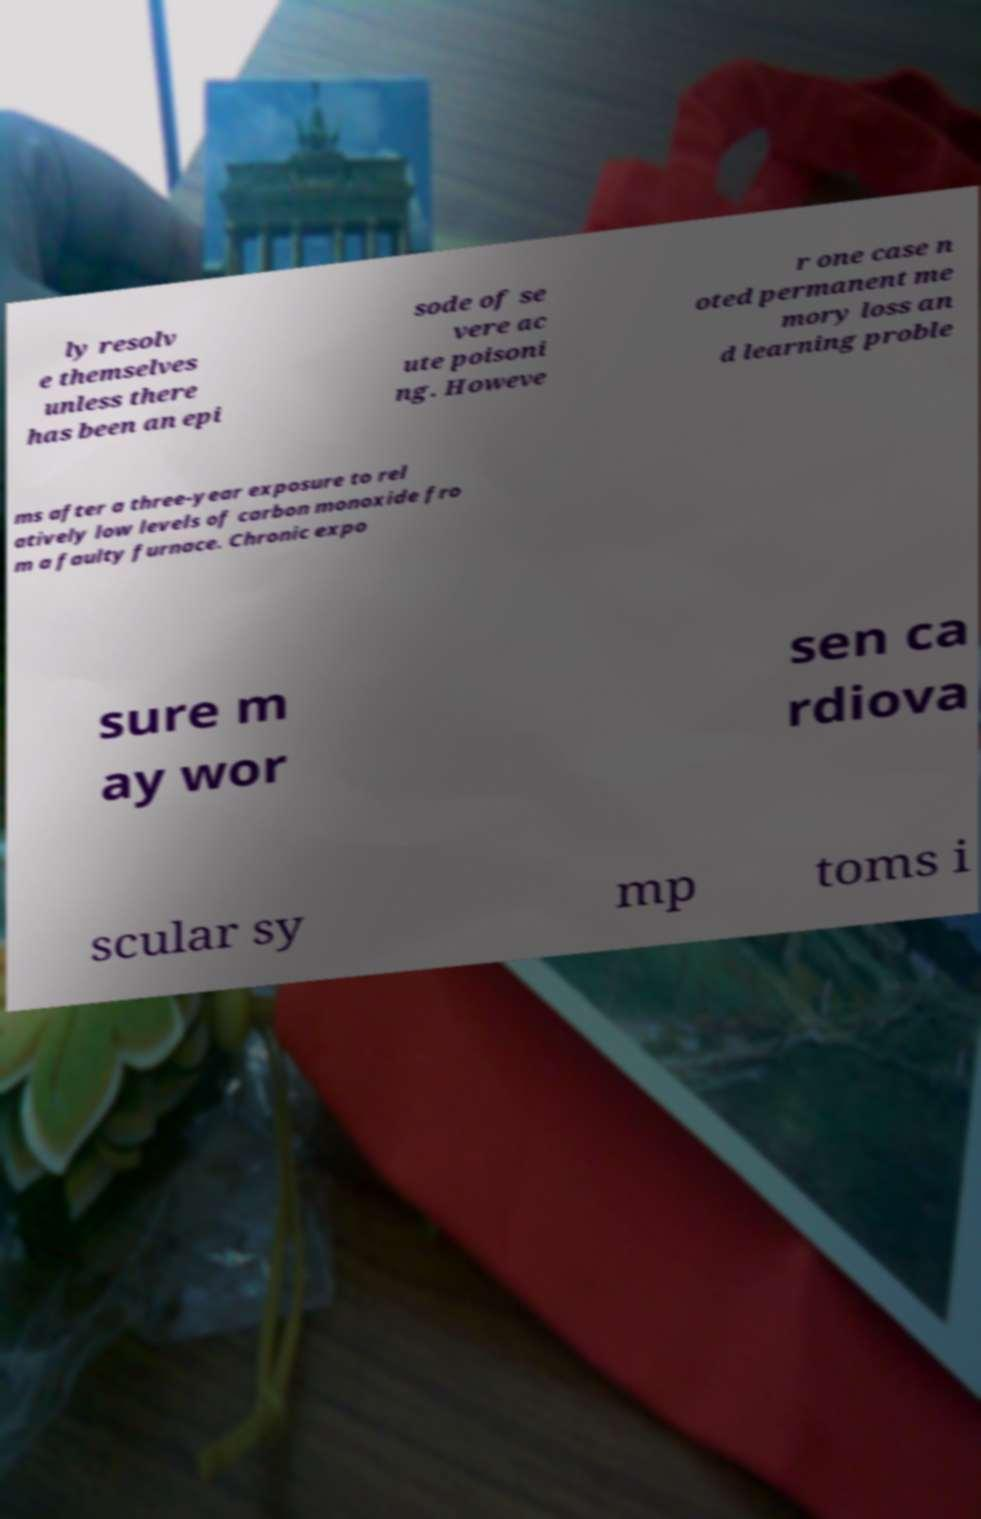Please identify and transcribe the text found in this image. ly resolv e themselves unless there has been an epi sode of se vere ac ute poisoni ng. Howeve r one case n oted permanent me mory loss an d learning proble ms after a three-year exposure to rel atively low levels of carbon monoxide fro m a faulty furnace. Chronic expo sure m ay wor sen ca rdiova scular sy mp toms i 